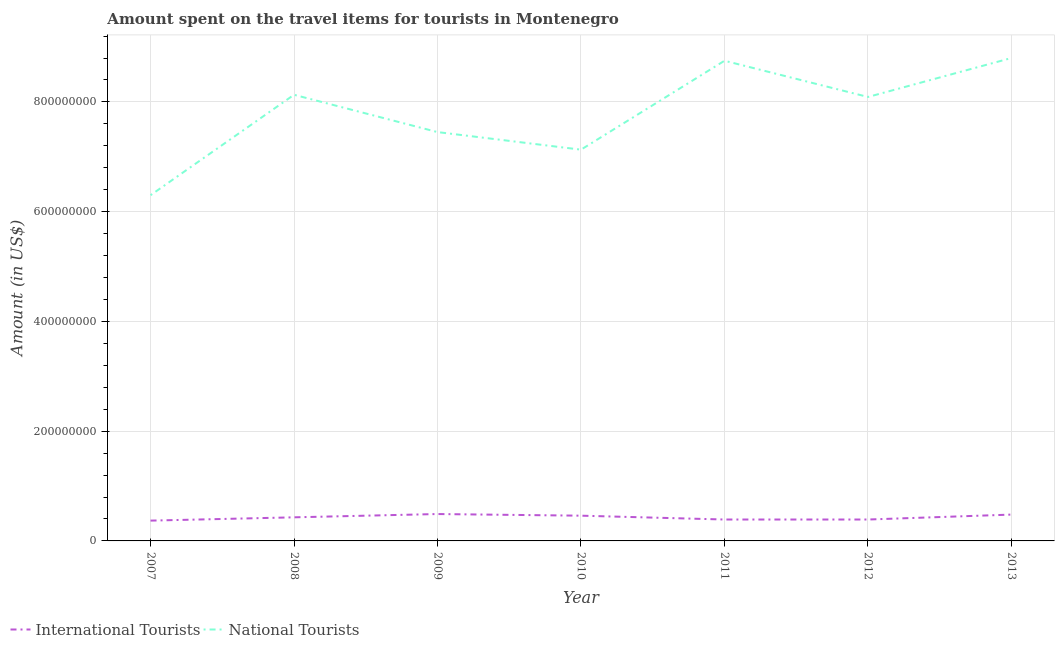How many different coloured lines are there?
Offer a very short reply. 2. Does the line corresponding to amount spent on travel items of international tourists intersect with the line corresponding to amount spent on travel items of national tourists?
Offer a very short reply. No. Is the number of lines equal to the number of legend labels?
Keep it short and to the point. Yes. What is the amount spent on travel items of national tourists in 2012?
Offer a terse response. 8.09e+08. Across all years, what is the maximum amount spent on travel items of international tourists?
Your answer should be compact. 4.90e+07. Across all years, what is the minimum amount spent on travel items of national tourists?
Make the answer very short. 6.30e+08. What is the total amount spent on travel items of international tourists in the graph?
Make the answer very short. 3.01e+08. What is the difference between the amount spent on travel items of international tourists in 2007 and that in 2009?
Keep it short and to the point. -1.20e+07. What is the difference between the amount spent on travel items of national tourists in 2012 and the amount spent on travel items of international tourists in 2008?
Keep it short and to the point. 7.66e+08. What is the average amount spent on travel items of national tourists per year?
Make the answer very short. 7.81e+08. In the year 2007, what is the difference between the amount spent on travel items of national tourists and amount spent on travel items of international tourists?
Keep it short and to the point. 5.93e+08. What is the ratio of the amount spent on travel items of international tourists in 2007 to that in 2008?
Your response must be concise. 0.86. Is the amount spent on travel items of national tourists in 2010 less than that in 2012?
Your answer should be compact. Yes. What is the difference between the highest and the second highest amount spent on travel items of national tourists?
Offer a very short reply. 5.00e+06. What is the difference between the highest and the lowest amount spent on travel items of international tourists?
Provide a succinct answer. 1.20e+07. Does the amount spent on travel items of national tourists monotonically increase over the years?
Keep it short and to the point. No. Is the amount spent on travel items of national tourists strictly greater than the amount spent on travel items of international tourists over the years?
Make the answer very short. Yes. Is the amount spent on travel items of national tourists strictly less than the amount spent on travel items of international tourists over the years?
Ensure brevity in your answer.  No. How many lines are there?
Your answer should be compact. 2. Does the graph contain any zero values?
Ensure brevity in your answer.  No. Where does the legend appear in the graph?
Your answer should be very brief. Bottom left. How are the legend labels stacked?
Keep it short and to the point. Horizontal. What is the title of the graph?
Provide a short and direct response. Amount spent on the travel items for tourists in Montenegro. What is the label or title of the X-axis?
Provide a short and direct response. Year. What is the label or title of the Y-axis?
Give a very brief answer. Amount (in US$). What is the Amount (in US$) in International Tourists in 2007?
Offer a very short reply. 3.70e+07. What is the Amount (in US$) of National Tourists in 2007?
Your answer should be very brief. 6.30e+08. What is the Amount (in US$) in International Tourists in 2008?
Ensure brevity in your answer.  4.30e+07. What is the Amount (in US$) of National Tourists in 2008?
Ensure brevity in your answer.  8.13e+08. What is the Amount (in US$) of International Tourists in 2009?
Give a very brief answer. 4.90e+07. What is the Amount (in US$) of National Tourists in 2009?
Offer a terse response. 7.45e+08. What is the Amount (in US$) in International Tourists in 2010?
Your response must be concise. 4.60e+07. What is the Amount (in US$) in National Tourists in 2010?
Offer a terse response. 7.13e+08. What is the Amount (in US$) of International Tourists in 2011?
Provide a short and direct response. 3.90e+07. What is the Amount (in US$) in National Tourists in 2011?
Provide a short and direct response. 8.75e+08. What is the Amount (in US$) in International Tourists in 2012?
Give a very brief answer. 3.90e+07. What is the Amount (in US$) in National Tourists in 2012?
Ensure brevity in your answer.  8.09e+08. What is the Amount (in US$) in International Tourists in 2013?
Keep it short and to the point. 4.80e+07. What is the Amount (in US$) in National Tourists in 2013?
Ensure brevity in your answer.  8.80e+08. Across all years, what is the maximum Amount (in US$) of International Tourists?
Your response must be concise. 4.90e+07. Across all years, what is the maximum Amount (in US$) of National Tourists?
Provide a succinct answer. 8.80e+08. Across all years, what is the minimum Amount (in US$) of International Tourists?
Your answer should be very brief. 3.70e+07. Across all years, what is the minimum Amount (in US$) of National Tourists?
Offer a terse response. 6.30e+08. What is the total Amount (in US$) in International Tourists in the graph?
Ensure brevity in your answer.  3.01e+08. What is the total Amount (in US$) of National Tourists in the graph?
Your answer should be compact. 5.46e+09. What is the difference between the Amount (in US$) in International Tourists in 2007 and that in 2008?
Your answer should be compact. -6.00e+06. What is the difference between the Amount (in US$) in National Tourists in 2007 and that in 2008?
Make the answer very short. -1.83e+08. What is the difference between the Amount (in US$) in International Tourists in 2007 and that in 2009?
Offer a terse response. -1.20e+07. What is the difference between the Amount (in US$) of National Tourists in 2007 and that in 2009?
Offer a very short reply. -1.15e+08. What is the difference between the Amount (in US$) of International Tourists in 2007 and that in 2010?
Ensure brevity in your answer.  -9.00e+06. What is the difference between the Amount (in US$) of National Tourists in 2007 and that in 2010?
Offer a terse response. -8.30e+07. What is the difference between the Amount (in US$) of International Tourists in 2007 and that in 2011?
Make the answer very short. -2.00e+06. What is the difference between the Amount (in US$) in National Tourists in 2007 and that in 2011?
Provide a succinct answer. -2.45e+08. What is the difference between the Amount (in US$) in National Tourists in 2007 and that in 2012?
Provide a succinct answer. -1.79e+08. What is the difference between the Amount (in US$) of International Tourists in 2007 and that in 2013?
Give a very brief answer. -1.10e+07. What is the difference between the Amount (in US$) in National Tourists in 2007 and that in 2013?
Keep it short and to the point. -2.50e+08. What is the difference between the Amount (in US$) in International Tourists in 2008 and that in 2009?
Keep it short and to the point. -6.00e+06. What is the difference between the Amount (in US$) of National Tourists in 2008 and that in 2009?
Your response must be concise. 6.80e+07. What is the difference between the Amount (in US$) in International Tourists in 2008 and that in 2010?
Ensure brevity in your answer.  -3.00e+06. What is the difference between the Amount (in US$) of National Tourists in 2008 and that in 2010?
Keep it short and to the point. 1.00e+08. What is the difference between the Amount (in US$) in National Tourists in 2008 and that in 2011?
Give a very brief answer. -6.20e+07. What is the difference between the Amount (in US$) of International Tourists in 2008 and that in 2013?
Your response must be concise. -5.00e+06. What is the difference between the Amount (in US$) of National Tourists in 2008 and that in 2013?
Offer a terse response. -6.70e+07. What is the difference between the Amount (in US$) of National Tourists in 2009 and that in 2010?
Your answer should be very brief. 3.20e+07. What is the difference between the Amount (in US$) of National Tourists in 2009 and that in 2011?
Your response must be concise. -1.30e+08. What is the difference between the Amount (in US$) in National Tourists in 2009 and that in 2012?
Make the answer very short. -6.40e+07. What is the difference between the Amount (in US$) in National Tourists in 2009 and that in 2013?
Your answer should be compact. -1.35e+08. What is the difference between the Amount (in US$) of National Tourists in 2010 and that in 2011?
Offer a terse response. -1.62e+08. What is the difference between the Amount (in US$) of International Tourists in 2010 and that in 2012?
Your answer should be compact. 7.00e+06. What is the difference between the Amount (in US$) of National Tourists in 2010 and that in 2012?
Provide a succinct answer. -9.60e+07. What is the difference between the Amount (in US$) of National Tourists in 2010 and that in 2013?
Your answer should be very brief. -1.67e+08. What is the difference between the Amount (in US$) in International Tourists in 2011 and that in 2012?
Provide a short and direct response. 0. What is the difference between the Amount (in US$) of National Tourists in 2011 and that in 2012?
Ensure brevity in your answer.  6.60e+07. What is the difference between the Amount (in US$) in International Tourists in 2011 and that in 2013?
Keep it short and to the point. -9.00e+06. What is the difference between the Amount (in US$) in National Tourists in 2011 and that in 2013?
Give a very brief answer. -5.00e+06. What is the difference between the Amount (in US$) of International Tourists in 2012 and that in 2013?
Offer a terse response. -9.00e+06. What is the difference between the Amount (in US$) in National Tourists in 2012 and that in 2013?
Keep it short and to the point. -7.10e+07. What is the difference between the Amount (in US$) in International Tourists in 2007 and the Amount (in US$) in National Tourists in 2008?
Your answer should be very brief. -7.76e+08. What is the difference between the Amount (in US$) in International Tourists in 2007 and the Amount (in US$) in National Tourists in 2009?
Offer a terse response. -7.08e+08. What is the difference between the Amount (in US$) of International Tourists in 2007 and the Amount (in US$) of National Tourists in 2010?
Your response must be concise. -6.76e+08. What is the difference between the Amount (in US$) of International Tourists in 2007 and the Amount (in US$) of National Tourists in 2011?
Ensure brevity in your answer.  -8.38e+08. What is the difference between the Amount (in US$) in International Tourists in 2007 and the Amount (in US$) in National Tourists in 2012?
Make the answer very short. -7.72e+08. What is the difference between the Amount (in US$) in International Tourists in 2007 and the Amount (in US$) in National Tourists in 2013?
Your answer should be very brief. -8.43e+08. What is the difference between the Amount (in US$) in International Tourists in 2008 and the Amount (in US$) in National Tourists in 2009?
Your answer should be compact. -7.02e+08. What is the difference between the Amount (in US$) of International Tourists in 2008 and the Amount (in US$) of National Tourists in 2010?
Keep it short and to the point. -6.70e+08. What is the difference between the Amount (in US$) of International Tourists in 2008 and the Amount (in US$) of National Tourists in 2011?
Provide a short and direct response. -8.32e+08. What is the difference between the Amount (in US$) of International Tourists in 2008 and the Amount (in US$) of National Tourists in 2012?
Keep it short and to the point. -7.66e+08. What is the difference between the Amount (in US$) in International Tourists in 2008 and the Amount (in US$) in National Tourists in 2013?
Offer a terse response. -8.37e+08. What is the difference between the Amount (in US$) of International Tourists in 2009 and the Amount (in US$) of National Tourists in 2010?
Provide a succinct answer. -6.64e+08. What is the difference between the Amount (in US$) of International Tourists in 2009 and the Amount (in US$) of National Tourists in 2011?
Ensure brevity in your answer.  -8.26e+08. What is the difference between the Amount (in US$) of International Tourists in 2009 and the Amount (in US$) of National Tourists in 2012?
Offer a terse response. -7.60e+08. What is the difference between the Amount (in US$) of International Tourists in 2009 and the Amount (in US$) of National Tourists in 2013?
Offer a terse response. -8.31e+08. What is the difference between the Amount (in US$) of International Tourists in 2010 and the Amount (in US$) of National Tourists in 2011?
Offer a terse response. -8.29e+08. What is the difference between the Amount (in US$) in International Tourists in 2010 and the Amount (in US$) in National Tourists in 2012?
Provide a short and direct response. -7.63e+08. What is the difference between the Amount (in US$) of International Tourists in 2010 and the Amount (in US$) of National Tourists in 2013?
Your answer should be very brief. -8.34e+08. What is the difference between the Amount (in US$) of International Tourists in 2011 and the Amount (in US$) of National Tourists in 2012?
Ensure brevity in your answer.  -7.70e+08. What is the difference between the Amount (in US$) in International Tourists in 2011 and the Amount (in US$) in National Tourists in 2013?
Ensure brevity in your answer.  -8.41e+08. What is the difference between the Amount (in US$) of International Tourists in 2012 and the Amount (in US$) of National Tourists in 2013?
Make the answer very short. -8.41e+08. What is the average Amount (in US$) in International Tourists per year?
Keep it short and to the point. 4.30e+07. What is the average Amount (in US$) in National Tourists per year?
Make the answer very short. 7.81e+08. In the year 2007, what is the difference between the Amount (in US$) in International Tourists and Amount (in US$) in National Tourists?
Your answer should be compact. -5.93e+08. In the year 2008, what is the difference between the Amount (in US$) in International Tourists and Amount (in US$) in National Tourists?
Your response must be concise. -7.70e+08. In the year 2009, what is the difference between the Amount (in US$) of International Tourists and Amount (in US$) of National Tourists?
Give a very brief answer. -6.96e+08. In the year 2010, what is the difference between the Amount (in US$) of International Tourists and Amount (in US$) of National Tourists?
Your response must be concise. -6.67e+08. In the year 2011, what is the difference between the Amount (in US$) of International Tourists and Amount (in US$) of National Tourists?
Your response must be concise. -8.36e+08. In the year 2012, what is the difference between the Amount (in US$) of International Tourists and Amount (in US$) of National Tourists?
Offer a terse response. -7.70e+08. In the year 2013, what is the difference between the Amount (in US$) of International Tourists and Amount (in US$) of National Tourists?
Offer a terse response. -8.32e+08. What is the ratio of the Amount (in US$) in International Tourists in 2007 to that in 2008?
Your answer should be very brief. 0.86. What is the ratio of the Amount (in US$) in National Tourists in 2007 to that in 2008?
Offer a very short reply. 0.77. What is the ratio of the Amount (in US$) in International Tourists in 2007 to that in 2009?
Keep it short and to the point. 0.76. What is the ratio of the Amount (in US$) in National Tourists in 2007 to that in 2009?
Your answer should be very brief. 0.85. What is the ratio of the Amount (in US$) of International Tourists in 2007 to that in 2010?
Keep it short and to the point. 0.8. What is the ratio of the Amount (in US$) in National Tourists in 2007 to that in 2010?
Make the answer very short. 0.88. What is the ratio of the Amount (in US$) in International Tourists in 2007 to that in 2011?
Make the answer very short. 0.95. What is the ratio of the Amount (in US$) of National Tourists in 2007 to that in 2011?
Offer a terse response. 0.72. What is the ratio of the Amount (in US$) of International Tourists in 2007 to that in 2012?
Provide a short and direct response. 0.95. What is the ratio of the Amount (in US$) in National Tourists in 2007 to that in 2012?
Your response must be concise. 0.78. What is the ratio of the Amount (in US$) in International Tourists in 2007 to that in 2013?
Your response must be concise. 0.77. What is the ratio of the Amount (in US$) in National Tourists in 2007 to that in 2013?
Offer a terse response. 0.72. What is the ratio of the Amount (in US$) of International Tourists in 2008 to that in 2009?
Your answer should be compact. 0.88. What is the ratio of the Amount (in US$) in National Tourists in 2008 to that in 2009?
Give a very brief answer. 1.09. What is the ratio of the Amount (in US$) in International Tourists in 2008 to that in 2010?
Make the answer very short. 0.93. What is the ratio of the Amount (in US$) in National Tourists in 2008 to that in 2010?
Your response must be concise. 1.14. What is the ratio of the Amount (in US$) in International Tourists in 2008 to that in 2011?
Your response must be concise. 1.1. What is the ratio of the Amount (in US$) of National Tourists in 2008 to that in 2011?
Offer a very short reply. 0.93. What is the ratio of the Amount (in US$) in International Tourists in 2008 to that in 2012?
Provide a short and direct response. 1.1. What is the ratio of the Amount (in US$) of International Tourists in 2008 to that in 2013?
Your response must be concise. 0.9. What is the ratio of the Amount (in US$) of National Tourists in 2008 to that in 2013?
Keep it short and to the point. 0.92. What is the ratio of the Amount (in US$) in International Tourists in 2009 to that in 2010?
Your answer should be very brief. 1.07. What is the ratio of the Amount (in US$) of National Tourists in 2009 to that in 2010?
Offer a very short reply. 1.04. What is the ratio of the Amount (in US$) of International Tourists in 2009 to that in 2011?
Ensure brevity in your answer.  1.26. What is the ratio of the Amount (in US$) of National Tourists in 2009 to that in 2011?
Offer a very short reply. 0.85. What is the ratio of the Amount (in US$) of International Tourists in 2009 to that in 2012?
Keep it short and to the point. 1.26. What is the ratio of the Amount (in US$) in National Tourists in 2009 to that in 2012?
Make the answer very short. 0.92. What is the ratio of the Amount (in US$) of International Tourists in 2009 to that in 2013?
Give a very brief answer. 1.02. What is the ratio of the Amount (in US$) of National Tourists in 2009 to that in 2013?
Your answer should be compact. 0.85. What is the ratio of the Amount (in US$) of International Tourists in 2010 to that in 2011?
Your answer should be very brief. 1.18. What is the ratio of the Amount (in US$) in National Tourists in 2010 to that in 2011?
Your response must be concise. 0.81. What is the ratio of the Amount (in US$) of International Tourists in 2010 to that in 2012?
Your response must be concise. 1.18. What is the ratio of the Amount (in US$) in National Tourists in 2010 to that in 2012?
Provide a short and direct response. 0.88. What is the ratio of the Amount (in US$) in International Tourists in 2010 to that in 2013?
Make the answer very short. 0.96. What is the ratio of the Amount (in US$) of National Tourists in 2010 to that in 2013?
Offer a terse response. 0.81. What is the ratio of the Amount (in US$) in International Tourists in 2011 to that in 2012?
Ensure brevity in your answer.  1. What is the ratio of the Amount (in US$) of National Tourists in 2011 to that in 2012?
Offer a very short reply. 1.08. What is the ratio of the Amount (in US$) in International Tourists in 2011 to that in 2013?
Your answer should be compact. 0.81. What is the ratio of the Amount (in US$) of National Tourists in 2011 to that in 2013?
Offer a terse response. 0.99. What is the ratio of the Amount (in US$) of International Tourists in 2012 to that in 2013?
Provide a succinct answer. 0.81. What is the ratio of the Amount (in US$) of National Tourists in 2012 to that in 2013?
Give a very brief answer. 0.92. What is the difference between the highest and the second highest Amount (in US$) in International Tourists?
Make the answer very short. 1.00e+06. What is the difference between the highest and the lowest Amount (in US$) in National Tourists?
Your response must be concise. 2.50e+08. 